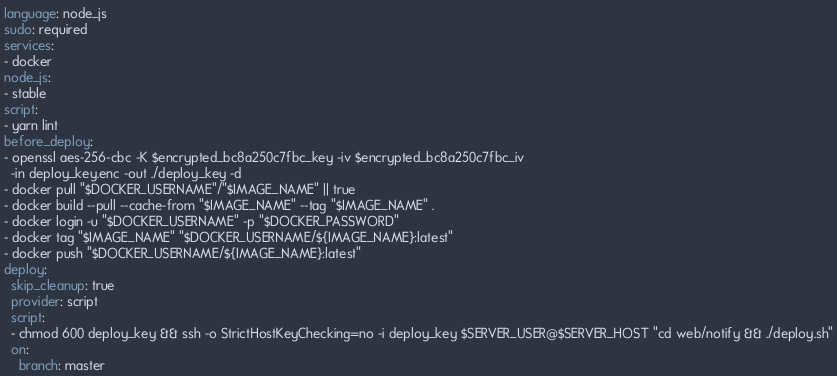<code> <loc_0><loc_0><loc_500><loc_500><_YAML_>language: node_js
sudo: required
services:
- docker
node_js:
- stable
script:
- yarn lint
before_deploy:
- openssl aes-256-cbc -K $encrypted_bc8a250c7fbc_key -iv $encrypted_bc8a250c7fbc_iv
  -in deploy_key.enc -out ./deploy_key -d
- docker pull "$DOCKER_USERNAME"/"$IMAGE_NAME" || true
- docker build --pull --cache-from "$IMAGE_NAME" --tag "$IMAGE_NAME" .
- docker login -u "$DOCKER_USERNAME" -p "$DOCKER_PASSWORD"
- docker tag "$IMAGE_NAME" "$DOCKER_USERNAME/${IMAGE_NAME}:latest"
- docker push "$DOCKER_USERNAME/${IMAGE_NAME}:latest"
deploy:
  skip_cleanup: true
  provider: script
  script:
  - chmod 600 deploy_key && ssh -o StrictHostKeyChecking=no -i deploy_key $SERVER_USER@$SERVER_HOST "cd web/notify && ./deploy.sh"
  on:
    branch: master
</code> 